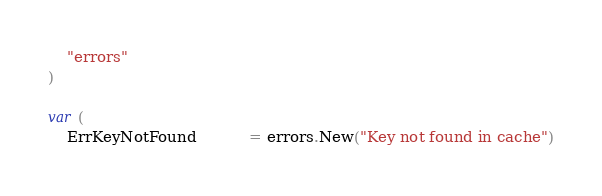<code> <loc_0><loc_0><loc_500><loc_500><_Go_>	"errors"
)

var (
	ErrKeyNotFound           = errors.New("Key not found in cache")</code> 